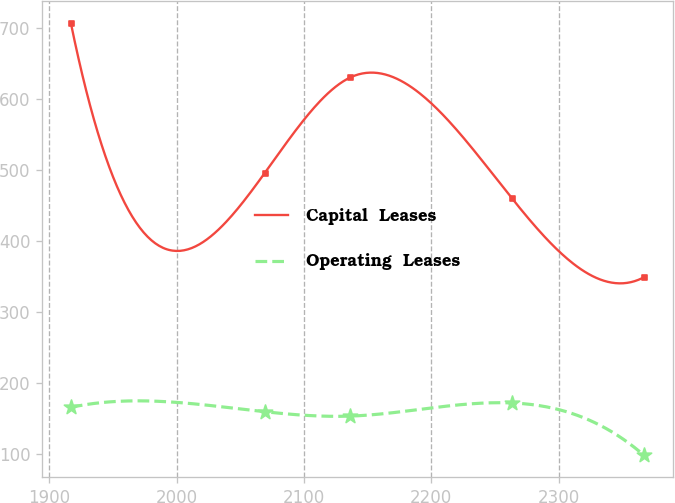<chart> <loc_0><loc_0><loc_500><loc_500><line_chart><ecel><fcel>Capital  Leases<fcel>Operating  Leases<nl><fcel>1916.92<fcel>706.39<fcel>165.08<nl><fcel>2069.12<fcel>495.09<fcel>158.91<nl><fcel>2136.33<fcel>629.82<fcel>152.74<nl><fcel>2263.41<fcel>459.31<fcel>171.25<nl><fcel>2367.17<fcel>348.55<fcel>97.28<nl></chart> 